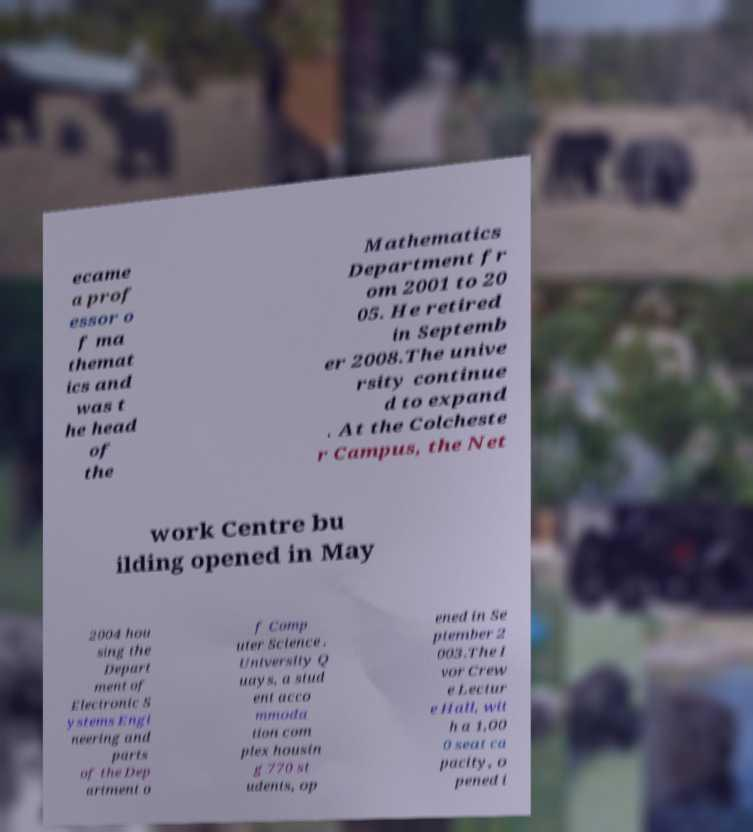Please identify and transcribe the text found in this image. ecame a prof essor o f ma themat ics and was t he head of the Mathematics Department fr om 2001 to 20 05. He retired in Septemb er 2008.The unive rsity continue d to expand . At the Colcheste r Campus, the Net work Centre bu ilding opened in May 2004 hou sing the Depart ment of Electronic S ystems Engi neering and parts of the Dep artment o f Comp uter Science . University Q uays, a stud ent acco mmoda tion com plex housin g 770 st udents, op ened in Se ptember 2 003.The I vor Crew e Lectur e Hall, wit h a 1,00 0 seat ca pacity, o pened i 